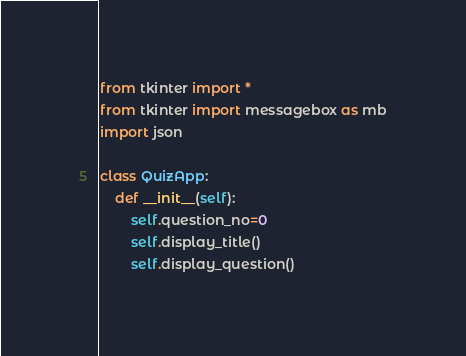Convert code to text. <code><loc_0><loc_0><loc_500><loc_500><_Python_>from tkinter import *
from tkinter import messagebox as mb
import json

class QuizApp:
	def __init__(self):		
		self.question_no=0			
		self.display_title()
		self.display_question()			</code> 